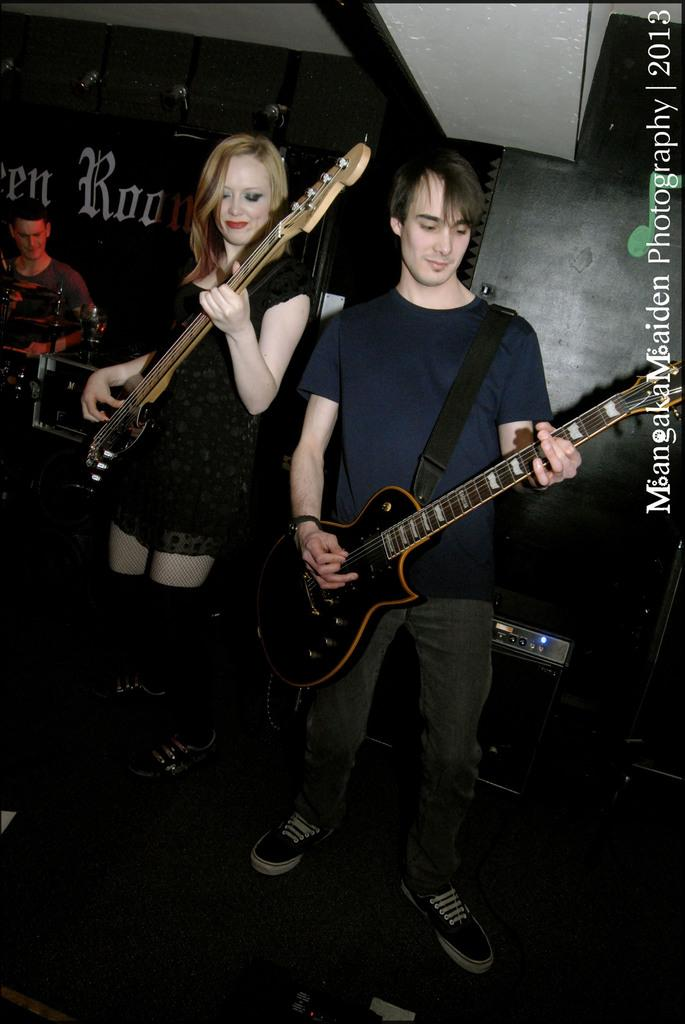How many people are in the image? There are two persons in the image. What are the two persons doing? The two persons are standing and playing a guitar. Can you describe the person in the background? There is a person in the background on the left side. How does the account balance change when the person on the left side of the image plays the guitar? There is no mention of an account or any financial transactions in the image, so it is not possible to determine how the account balance might change. 